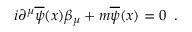Convert formula to latex. <formula><loc_0><loc_0><loc_500><loc_500>i \partial ^ { \mu } \overline { \psi } ( x ) \beta _ { \mu } + m \overline { \psi } ( x ) = 0 \, .</formula> 